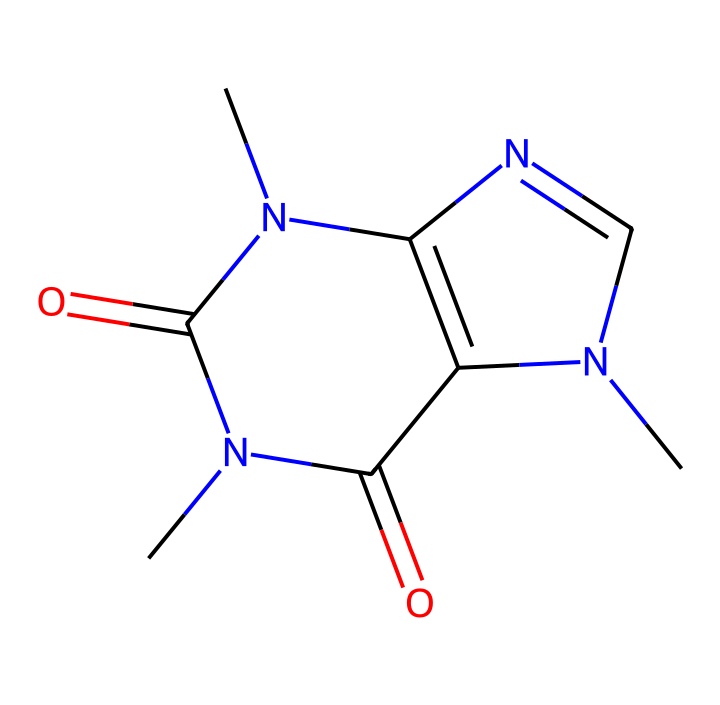What is the molecular formula of caffeine? By analyzing the SMILES representation, we can count the different atoms present: 8 carbon atoms (C), 10 hydrogen atoms (H), 4 nitrogen atoms (N), and 2 oxygen atoms (O). This gives us the formula C8H10N4O2.
Answer: C8H10N4O2 How many nitrogen atoms are in the caffeine molecule? Looking at the SMILES notation, we identify the nitrogen atoms as the 'N' symbols. Counting them yields four nitrogen atoms in total.
Answer: 4 What type of bond connects the carbon and oxygen in caffeine? The structure typically showcases carbonyl groups (C=O), which indicate double bonds between carbon and oxygen. Using the SMILES, we notice these double bonds in both instances where oxygen is present.
Answer: double bond Is caffeine a saturated or unsaturated compound? The presence of double bonds (C=O) in the structure indicates that the compound contains unsaturated bonds. Thus, we categorize caffeine as an unsaturated compound.
Answer: unsaturated What is the structural characteristic of caffeine that classifies it as a stimulant? Caffeine's ability to act as a stimulant is primarily due to the presence of nitrogen atoms arranged in a specific pattern (specifically, as part of the xanthine structure) that allows it to interact with adenosine receptors in the brain.
Answer: nitrogen atoms How many rings are present in the caffeine structure? By analyzing the SMILES, we observe that there are two fusion points between nitrogen and carbon that create two separate ring structures, one of which is a six-membered ring and the other is a five-membered ring. Thus, caffeine contains two rings.
Answer: 2 